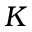Convert formula to latex. <formula><loc_0><loc_0><loc_500><loc_500>K</formula> 